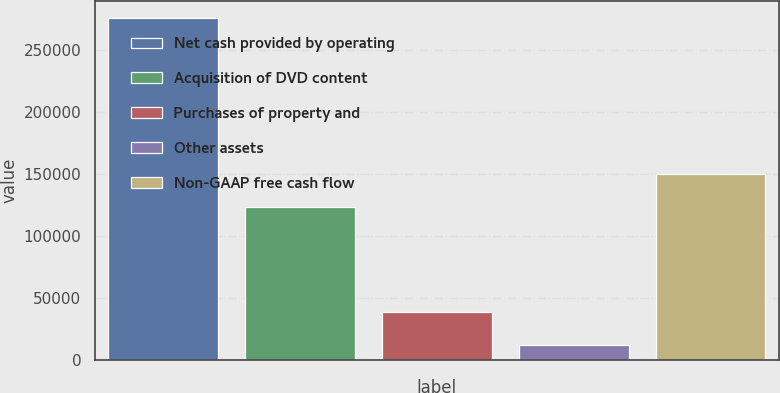Convert chart. <chart><loc_0><loc_0><loc_500><loc_500><bar_chart><fcel>Net cash provided by operating<fcel>Acquisition of DVD content<fcel>Purchases of property and<fcel>Other assets<fcel>Non-GAAP free cash flow<nl><fcel>276401<fcel>123901<fcel>38749.7<fcel>12344<fcel>150307<nl></chart> 